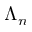Convert formula to latex. <formula><loc_0><loc_0><loc_500><loc_500>\Lambda _ { n }</formula> 